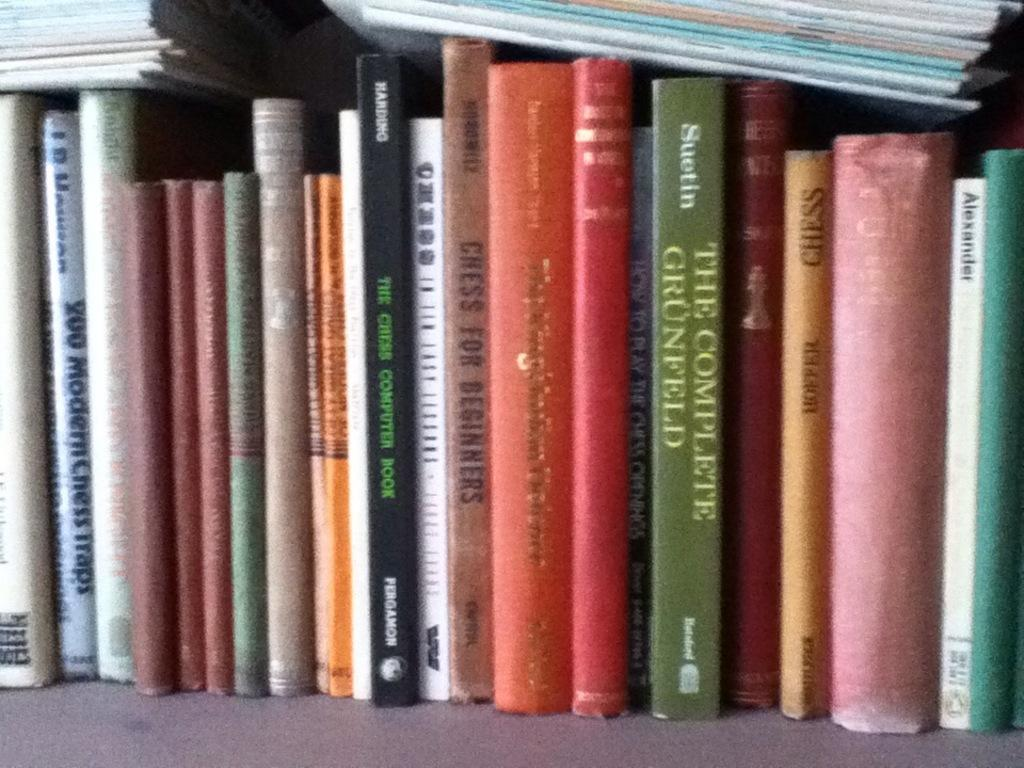<image>
Offer a succinct explanation of the picture presented. Multiple books on a book shelf, one of which is The complete GrunFeld. 